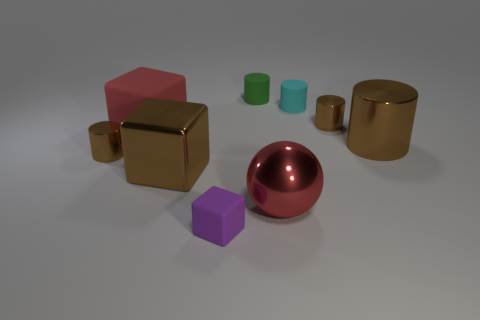There is a tiny brown object that is on the left side of the brown cube; is its shape the same as the brown thing that is behind the red block?
Give a very brief answer. Yes. Is there a brown shiny thing that has the same size as the brown cube?
Your response must be concise. Yes. What is the green cylinder to the right of the tiny purple rubber block made of?
Offer a terse response. Rubber. Are the cylinder on the left side of the purple block and the big red block made of the same material?
Your response must be concise. No. Are there any tiny brown shiny blocks?
Your answer should be very brief. No. What color is the other cube that is made of the same material as the small purple cube?
Provide a short and direct response. Red. The metallic cube that is behind the large red object that is on the right side of the tiny green cylinder that is behind the red matte block is what color?
Provide a short and direct response. Brown. Does the red metal thing have the same size as the red rubber cube that is in front of the small green rubber cylinder?
Ensure brevity in your answer.  Yes. What number of things are cylinders that are right of the small rubber block or rubber objects that are to the left of the brown metallic block?
Provide a succinct answer. 5. There is a brown thing that is the same size as the metal block; what shape is it?
Your answer should be very brief. Cylinder. 